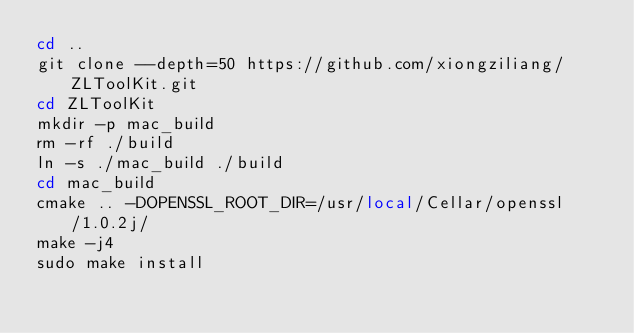<code> <loc_0><loc_0><loc_500><loc_500><_Bash_>cd ..
git clone --depth=50 https://github.com/xiongziliang/ZLToolKit.git
cd ZLToolKit
mkdir -p mac_build
rm -rf ./build
ln -s ./mac_build ./build
cd mac_build 
cmake .. -DOPENSSL_ROOT_DIR=/usr/local/Cellar/openssl/1.0.2j/
make -j4
sudo make install
</code> 